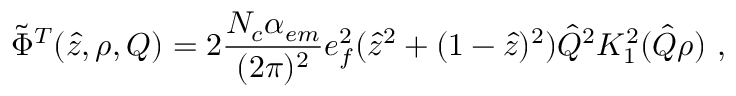<formula> <loc_0><loc_0><loc_500><loc_500>\tilde { \Phi } ^ { T } ( \hat { z } , \rho , Q ) = 2 { \frac { N _ { c } \alpha _ { e m } } { ( 2 \pi ) ^ { 2 } } } e _ { f } ^ { 2 } ( \hat { z } ^ { 2 } + ( 1 - \hat { z } ) ^ { 2 } ) \hat { Q } ^ { 2 } K _ { 1 } ^ { 2 } ( \hat { Q } \rho ) \, ,</formula> 